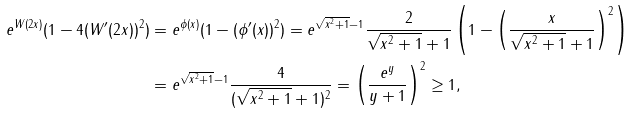<formula> <loc_0><loc_0><loc_500><loc_500>e ^ { W ( 2 x ) } ( 1 - 4 ( W ^ { \prime } ( 2 x ) ) ^ { 2 } ) & = e ^ { \phi ( x ) } ( 1 - ( \phi ^ { \prime } ( x ) ) ^ { 2 } ) = e ^ { \sqrt { x ^ { 2 } + 1 } - 1 } \frac { 2 } { \sqrt { x ^ { 2 } + 1 } + 1 } \left ( 1 - \left ( \frac { x } { \sqrt { x ^ { 2 } + 1 } + 1 } \right ) ^ { 2 } \right ) \\ & = e ^ { \sqrt { x ^ { 2 } + 1 } - 1 } \frac { 4 } { ( \sqrt { x ^ { 2 } + 1 } + 1 ) ^ { 2 } } = \left ( \frac { e ^ { y } } { y + 1 } \right ) ^ { 2 } \geq 1 ,</formula> 